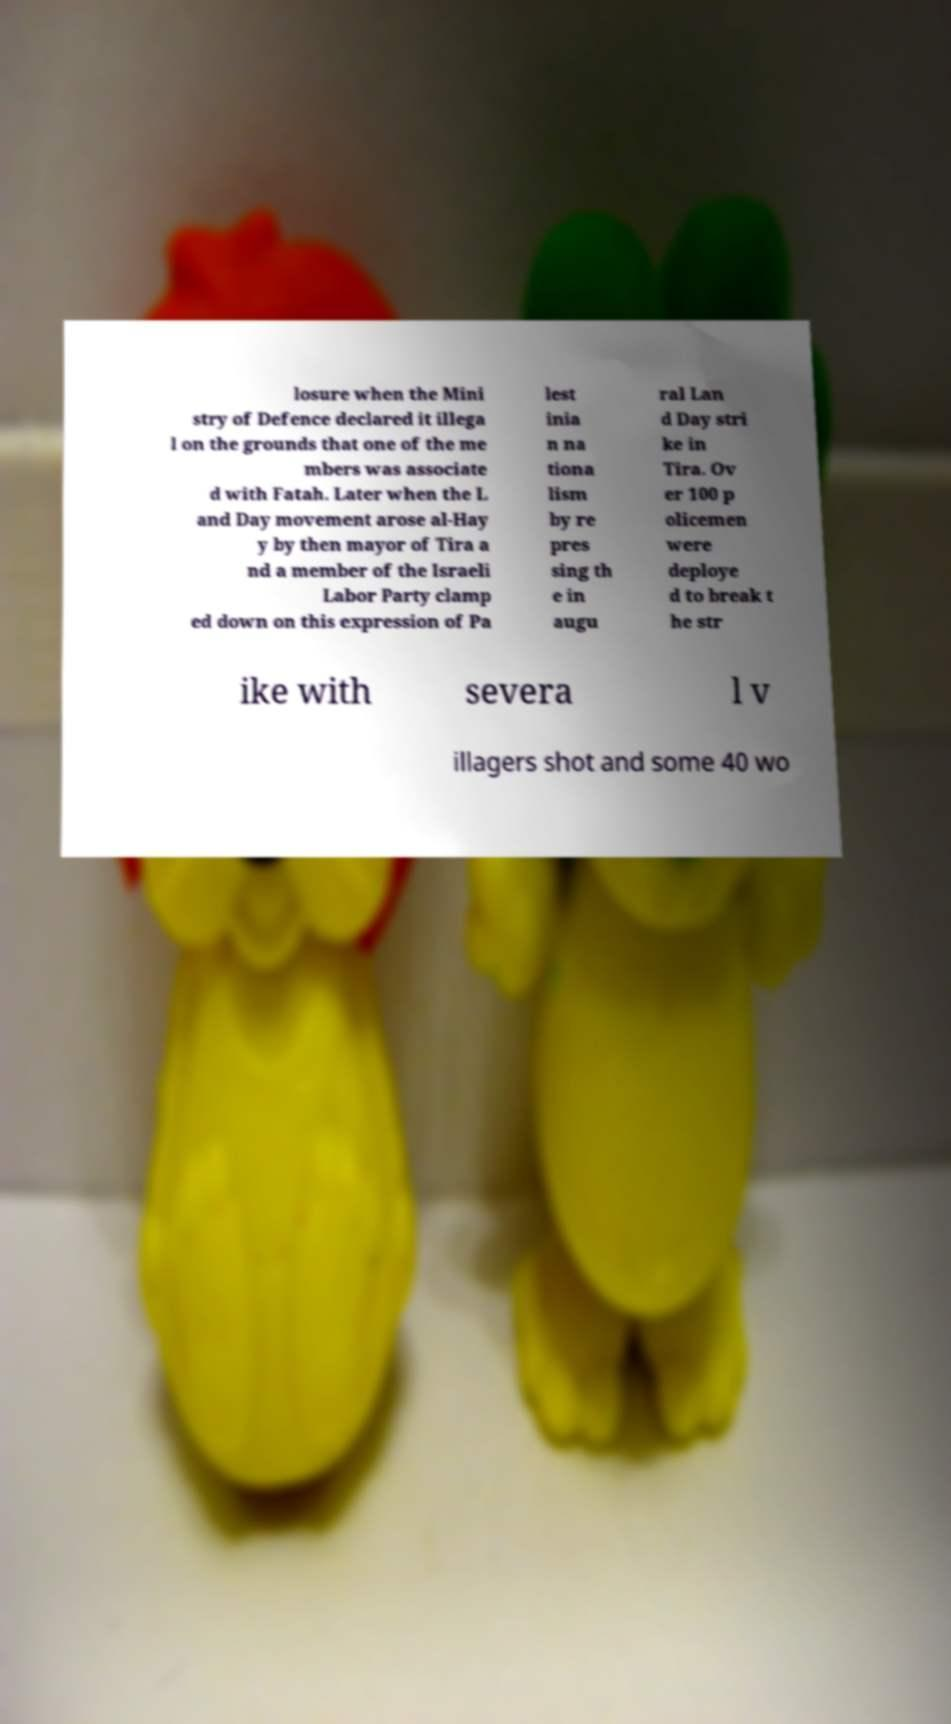Please read and relay the text visible in this image. What does it say? losure when the Mini stry of Defence declared it illega l on the grounds that one of the me mbers was associate d with Fatah. Later when the L and Day movement arose al-Hay y by then mayor of Tira a nd a member of the Israeli Labor Party clamp ed down on this expression of Pa lest inia n na tiona lism by re pres sing th e in augu ral Lan d Day stri ke in Tira. Ov er 100 p olicemen were deploye d to break t he str ike with severa l v illagers shot and some 40 wo 